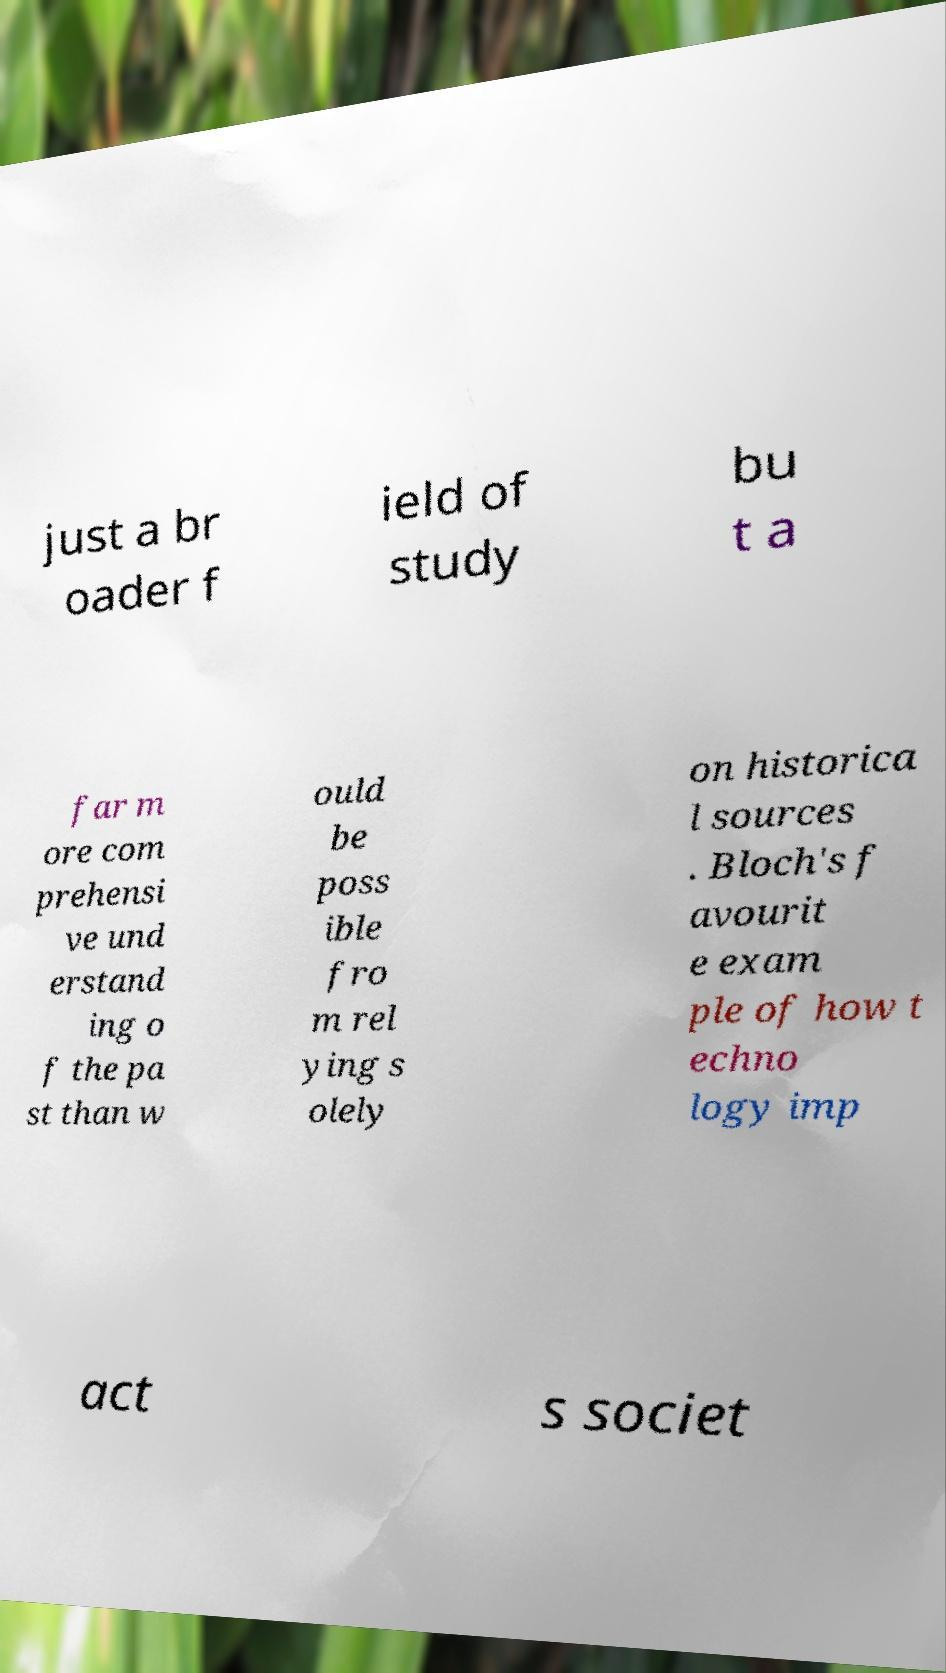Could you extract and type out the text from this image? just a br oader f ield of study bu t a far m ore com prehensi ve und erstand ing o f the pa st than w ould be poss ible fro m rel ying s olely on historica l sources . Bloch's f avourit e exam ple of how t echno logy imp act s societ 